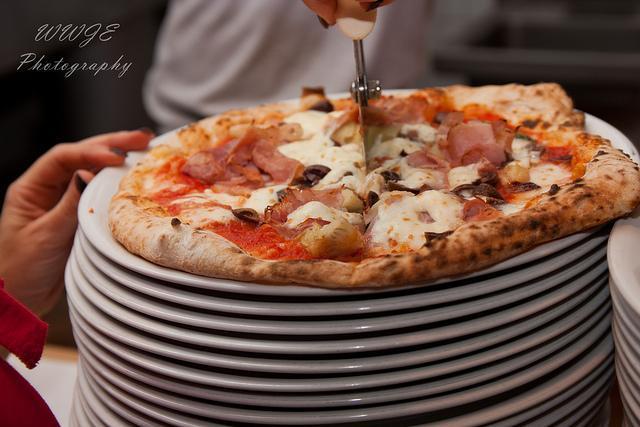How many pizzas are ready?
Give a very brief answer. 1. How many people can be seen?
Give a very brief answer. 2. 